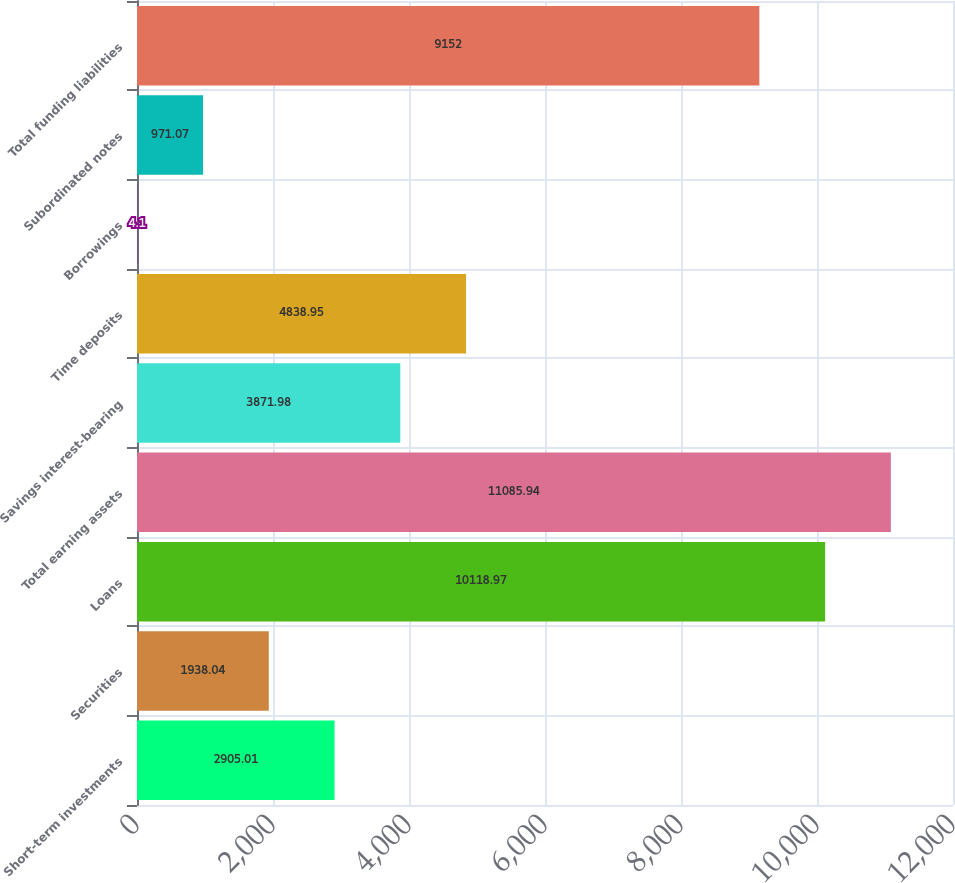Convert chart. <chart><loc_0><loc_0><loc_500><loc_500><bar_chart><fcel>Short-term investments<fcel>Securities<fcel>Loans<fcel>Total earning assets<fcel>Savings interest-bearing<fcel>Time deposits<fcel>Borrowings<fcel>Subordinated notes<fcel>Total funding liabilities<nl><fcel>2905.01<fcel>1938.04<fcel>10119<fcel>11085.9<fcel>3871.98<fcel>4838.95<fcel>4.1<fcel>971.07<fcel>9152<nl></chart> 